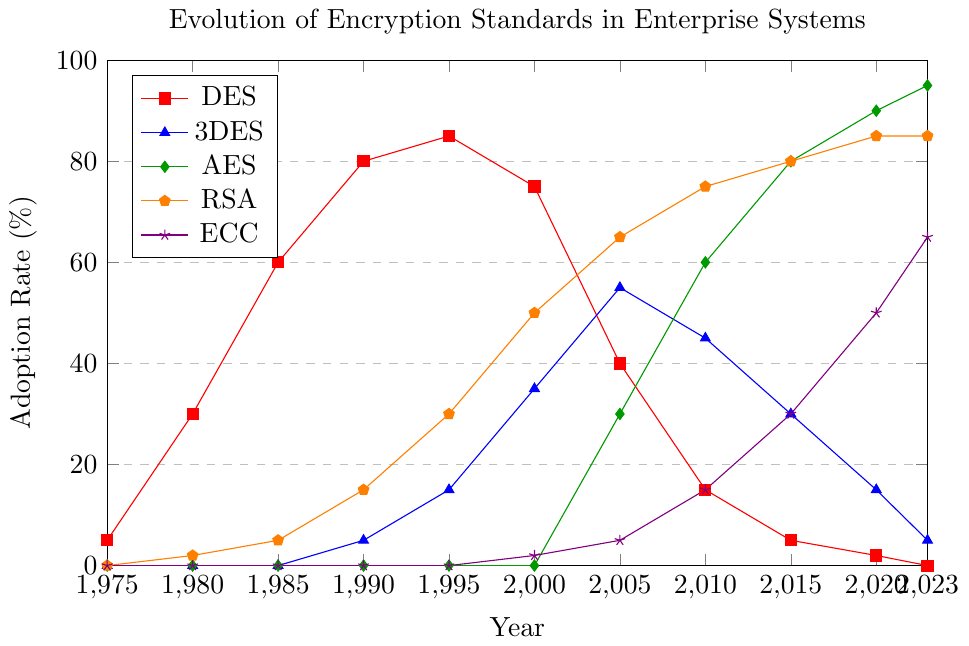What was the adoption rate of DES in 1995? Observe the data point for DES in 1995, which corresponds to the red line. The y-axis indicates that its adoption rate is 85%.
Answer: 85% Which encryption standard had the highest adoption rate in 2023? Compare the adoption rates of all encryption standards in 2023 by looking at the data points for DES, 3DES, AES, RSA, and ECC. AES has the highest adoption rate at 95%.
Answer: AES Between 2000 and 2020, which encryption standard saw the largest increase in adoption rate? Calculate the difference in adoption rates between 2020 and 2000 for each encryption standard: DES (-73%), 3DES (-20%), AES (90%), RSA (35%), ECC (48%). AES had the largest increase from 0% to 90%.
Answer: AES What was the sum of the adoption rates of RSA and ECC in 2010? Look at the adoption rates for RSA and ECC in 2010, which are 75% and 15%, respectively. Sum them up: 75% + 15% = 90%.
Answer: 90% In which year did AES surpass the 50% adoption rate? Trace the green line (AES) and identify the year at which it first crosses the 50% mark on the y-axis, which is in 2010.
Answer: 2010 Compare the adoption rates of DES and 3DES in 2005. How much higher was 3DES's adoption rate? Look at the 2005 data points: DES had an adoption rate of 40%, and 3DES had 55%. The difference is 55% - 40% = 15%.
Answer: 15% Which encryption standard showed a constant increase in adoption rates from 1975 to 2023 without any decline? Observe the trend lines of each standard. Only AES and RSA show a consistent increase without any dips.
Answer: AES and RSA What is the average adoption rate of ECC over the provided years? Sum up the adoption rates for ECC across all years (0 + 0 + 0 + 0 + 0 + 2 + 5 + 15 + 30 + 50 + 65) = 167, then divide by the number of years (11). The average is 167 / 11 ≈ 15.18%.
Answer: 15.18% In what year did RSA's adoption rate reach 30%? Trace the orange line representing RSA and find the corresponding year when it first reaches 30%, which is in 1995.
Answer: 1995 How many years did DES maintain an adoption rate of over 50%? Observe the red line and count the years when the DES adoption rate exceeded 50% (1985, 1990, 1995, 2000). DES maintained over 50% for 4 years.
Answer: 4 years 